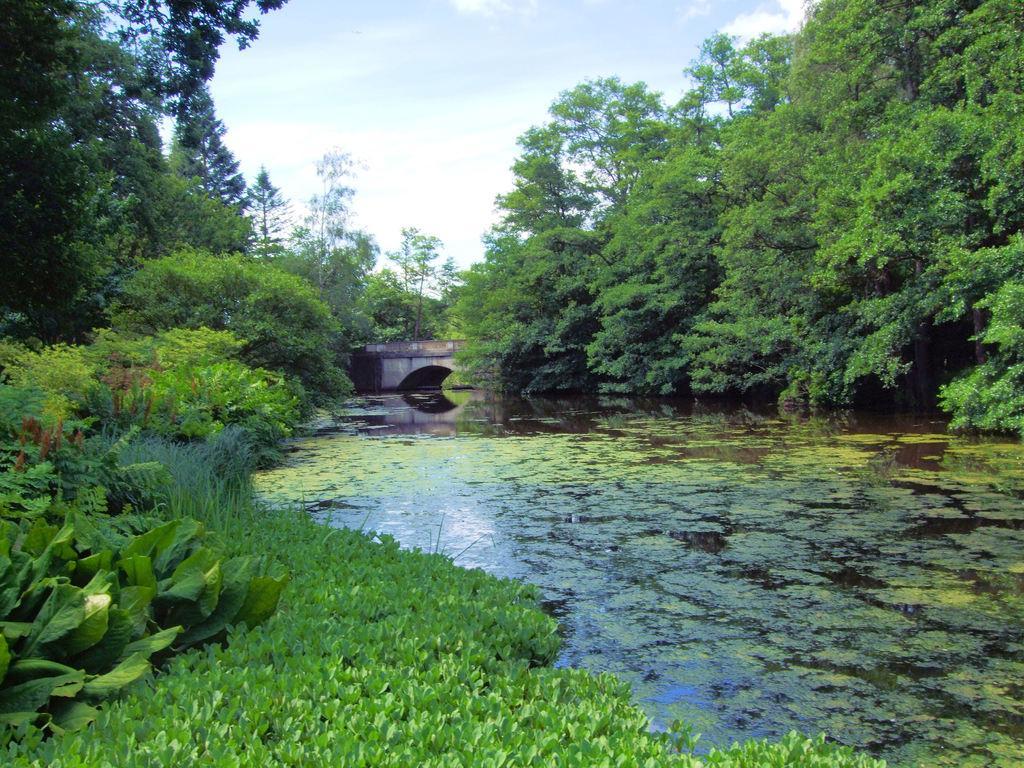How would you summarize this image in a sentence or two? In this image, we can see so many trees, plants and water with algae. Here there is a bridge. Top of the image, there is a sky. 